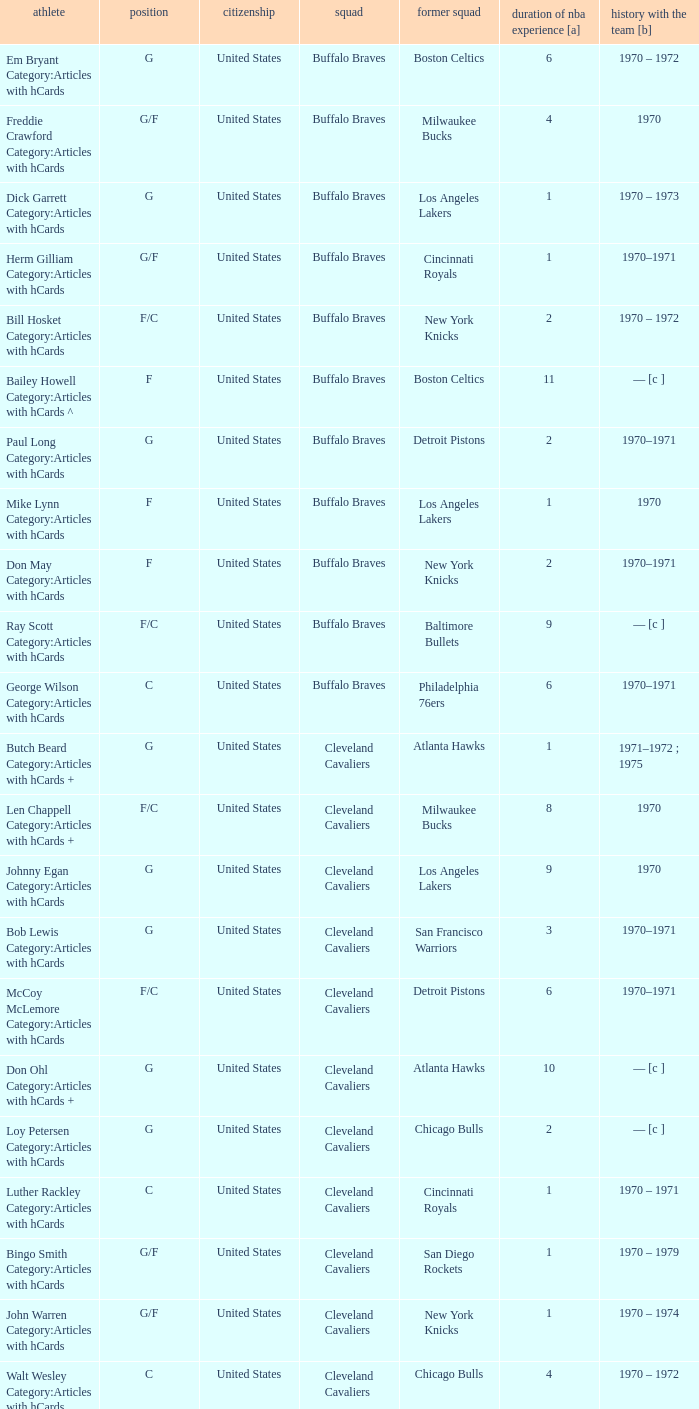Who is the player with 7 years of NBA experience? Larry Siegfried Category:Articles with hCards. 